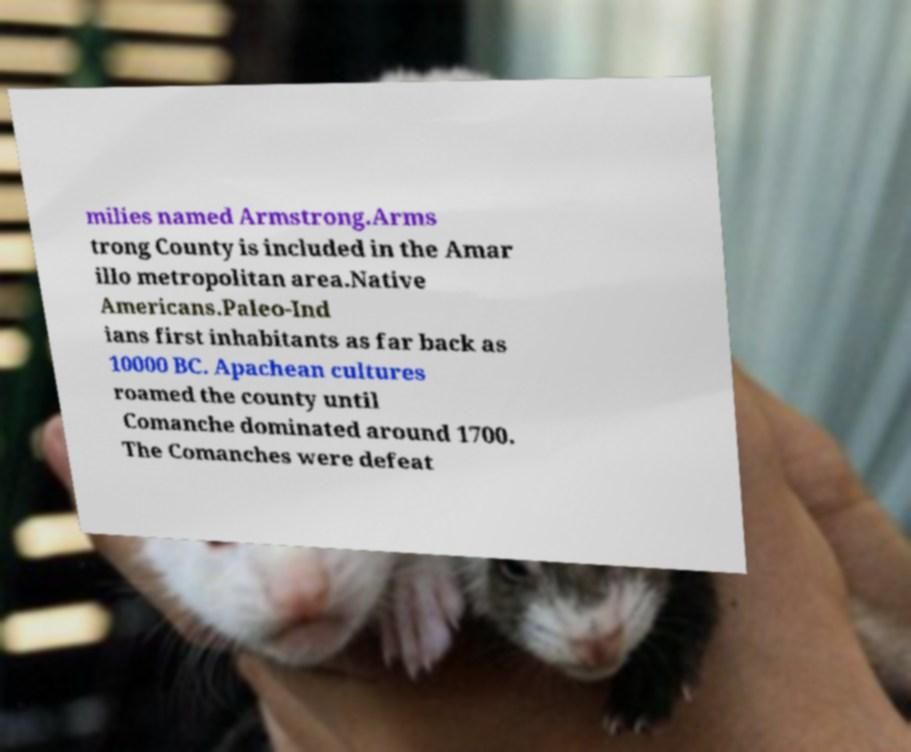Can you read and provide the text displayed in the image?This photo seems to have some interesting text. Can you extract and type it out for me? milies named Armstrong.Arms trong County is included in the Amar illo metropolitan area.Native Americans.Paleo-Ind ians first inhabitants as far back as 10000 BC. Apachean cultures roamed the county until Comanche dominated around 1700. The Comanches were defeat 